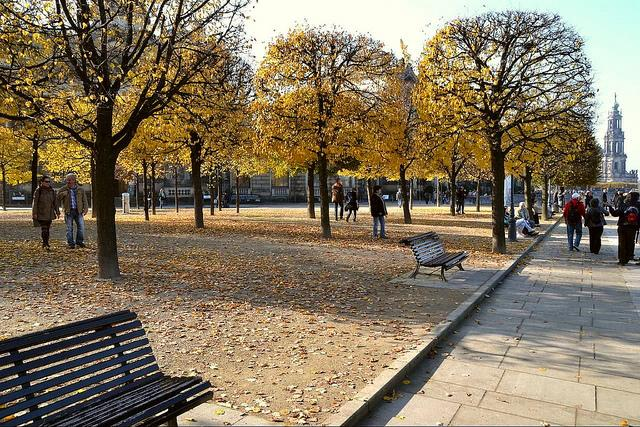How many months till the leaves turn green?

Choices:
A) 3-4
B) 1-2
C) 5-7
D) 10-12 5-7 